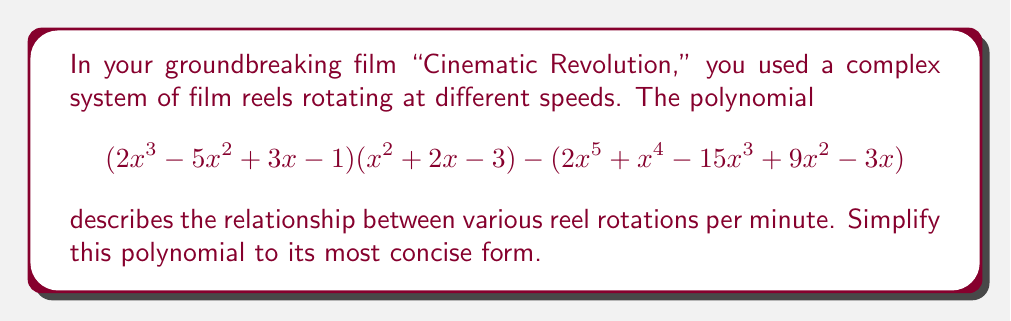Solve this math problem. Let's approach this step-by-step:

1) First, let's expand $(2x^3 - 5x^2 + 3x - 1)(x^2 + 2x - 3)$:
   $$(2x^3)(x^2) = 2x^5$$
   $$(2x^3)(2x) = 4x^4$$
   $$(2x^3)(-3) = -6x^3$$
   $$(-5x^2)(x^2) = -5x^4$$
   $$(-5x^2)(2x) = -10x^3$$
   $$(-5x^2)(-3) = 15x^2$$
   $$(3x)(x^2) = 3x^3$$
   $$(3x)(2x) = 6x^2$$
   $$(3x)(-3) = -9x$$
   $$(-1)(x^2) = -x^2$$
   $$(-1)(2x) = -2x$$
   $$(-1)(-3) = 3$$

2) Adding these terms:
   $$2x^5 + 4x^4 - 6x^3 - 5x^4 - 10x^3 + 15x^2 + 3x^3 + 6x^2 - 9x - x^2 - 2x + 3$$
   $$= 2x^5 - x^4 - 13x^3 + 20x^2 - 11x + 3$$

3) Now, we subtract the second part of the original expression:
   $$(2x^5 - x^4 - 13x^3 + 20x^2 - 11x + 3) - (2x^5 + x^4 - 15x^3 + 9x^2 - 3x)$$

4) Subtracting term by term:
   $$2x^5 - 2x^5 = 0$$
   $$-x^4 - x^4 = -2x^4$$
   $$-13x^3 - (-15x^3) = 2x^3$$
   $$20x^2 - 9x^2 = 11x^2$$
   $$-11x - (-3x) = -8x$$
   $$3 - 0 = 3$$

5) Therefore, the simplified polynomial is:
   $$-2x^4 + 2x^3 + 11x^2 - 8x + 3$$
Answer: $-2x^4 + 2x^3 + 11x^2 - 8x + 3$ 